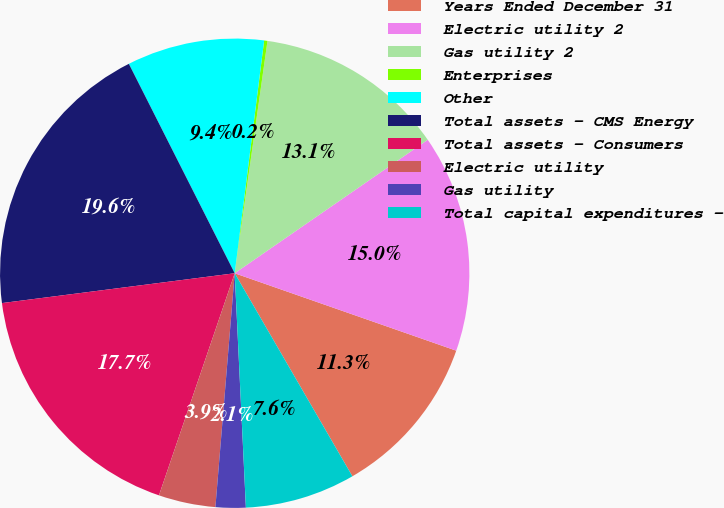Convert chart. <chart><loc_0><loc_0><loc_500><loc_500><pie_chart><fcel>Years Ended December 31<fcel>Electric utility 2<fcel>Gas utility 2<fcel>Enterprises<fcel>Other<fcel>Total assets - CMS Energy<fcel>Total assets - Consumers<fcel>Electric utility<fcel>Gas utility<fcel>Total capital expenditures -<nl><fcel>11.29%<fcel>14.98%<fcel>13.14%<fcel>0.23%<fcel>9.45%<fcel>19.58%<fcel>17.74%<fcel>3.92%<fcel>2.07%<fcel>7.6%<nl></chart> 